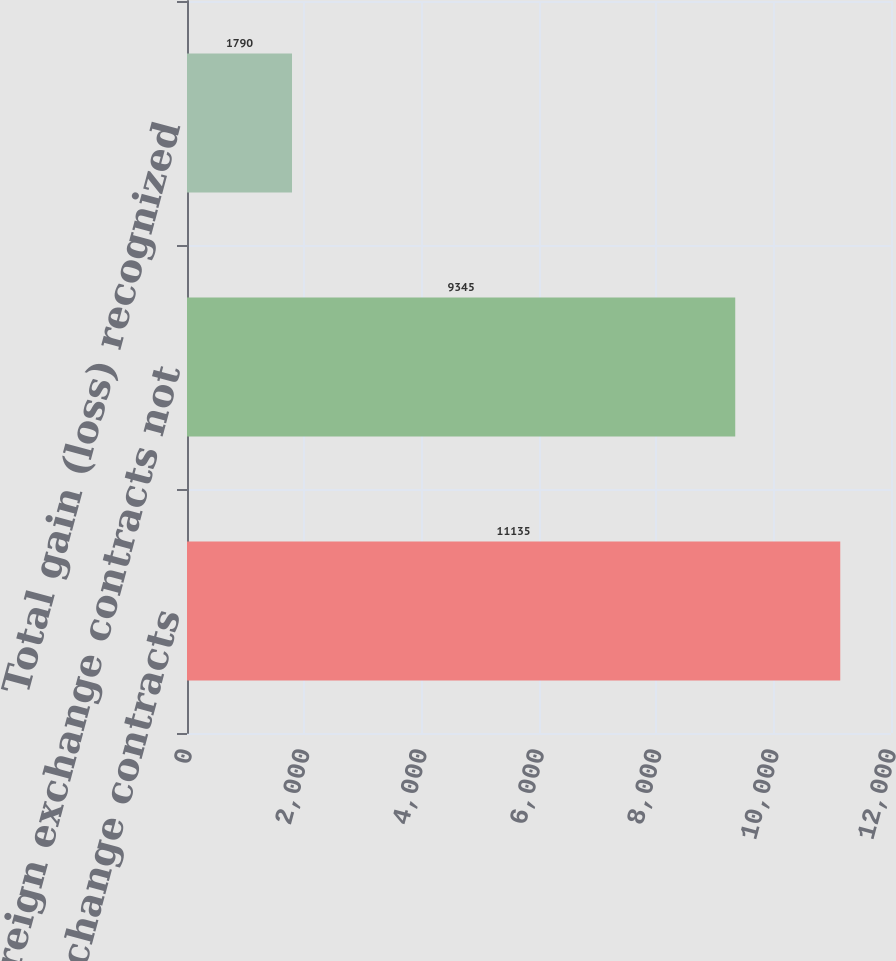<chart> <loc_0><loc_0><loc_500><loc_500><bar_chart><fcel>Foreign exchange contracts<fcel>Foreign exchange contracts not<fcel>Total gain (loss) recognized<nl><fcel>11135<fcel>9345<fcel>1790<nl></chart> 